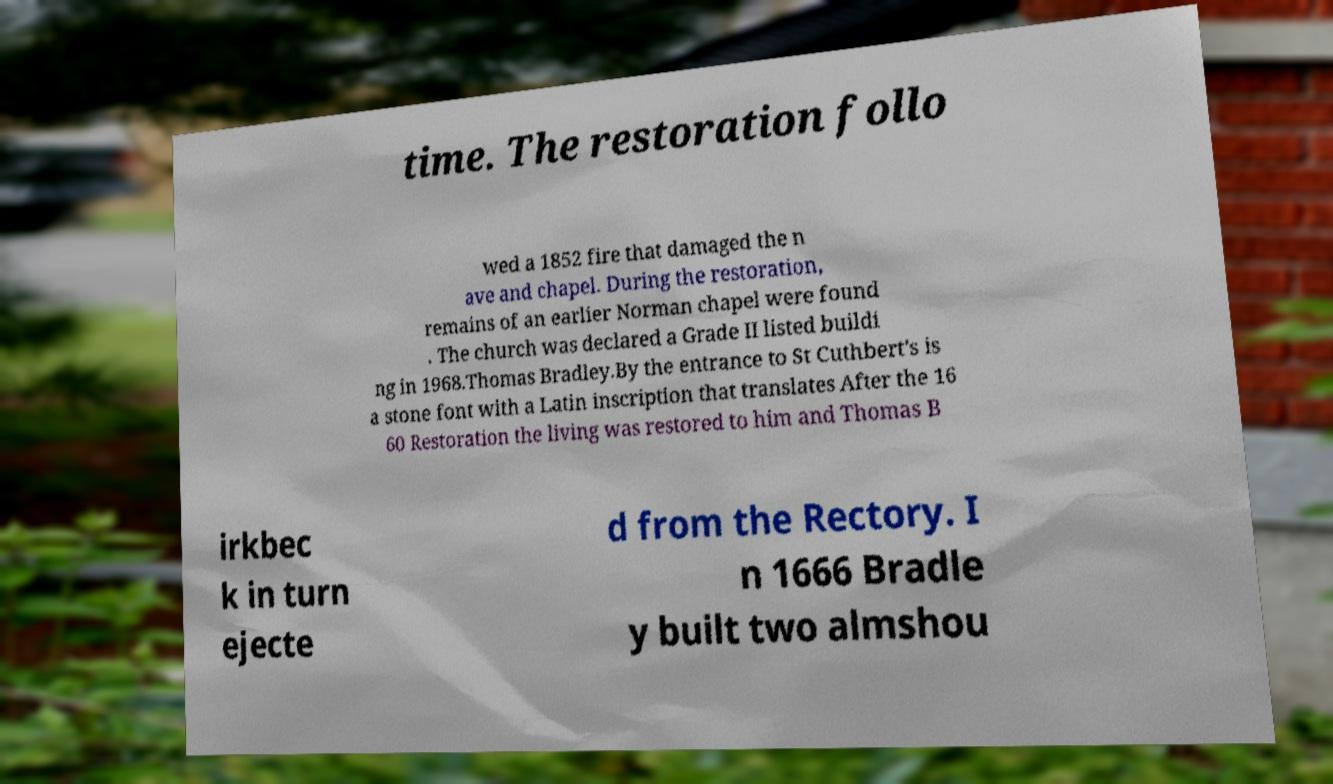Please read and relay the text visible in this image. What does it say? time. The restoration follo wed a 1852 fire that damaged the n ave and chapel. During the restoration, remains of an earlier Norman chapel were found . The church was declared a Grade II listed buildi ng in 1968.Thomas Bradley.By the entrance to St Cuthbert's is a stone font with a Latin inscription that translates After the 16 60 Restoration the living was restored to him and Thomas B irkbec k in turn ejecte d from the Rectory. I n 1666 Bradle y built two almshou 